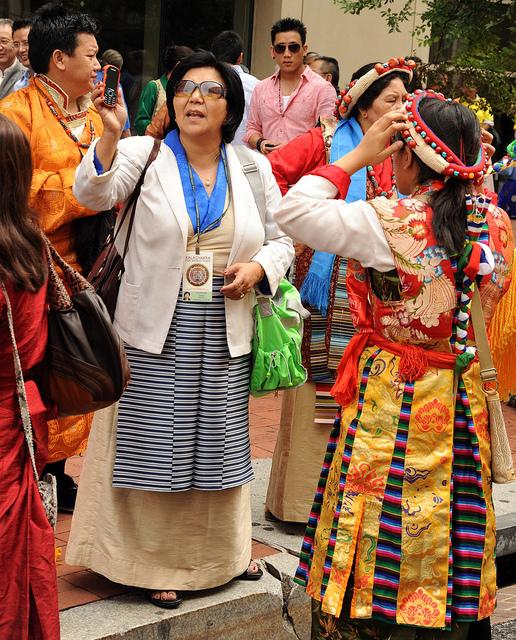Is the woman in the white jacket wearing sunglasses?
Keep it brief. Yes. What is the anachronism in the image?
Be succinct. Phone. How many women are in the photo?
Short answer required. 4. What color is the woman's skirt?
Answer briefly. Brown. 